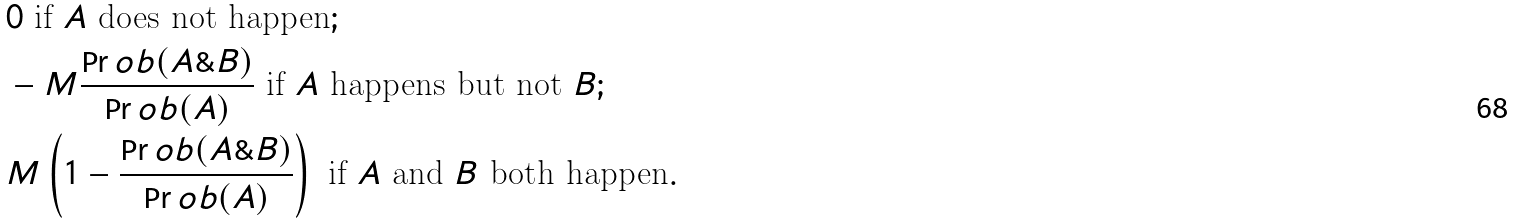Convert formula to latex. <formula><loc_0><loc_0><loc_500><loc_500>& 0 \text { if } A \text { does not happen} ; \\ & - M \frac { \Pr o b ( A \& B ) } { \Pr o b ( A ) } \text { if } A \text { happens but not } B ; \\ & M \left ( 1 - \frac { \Pr o b ( A \& B ) } { \Pr o b ( A ) } \right ) \text { if } A \text { and } B \text { both happen} .</formula> 